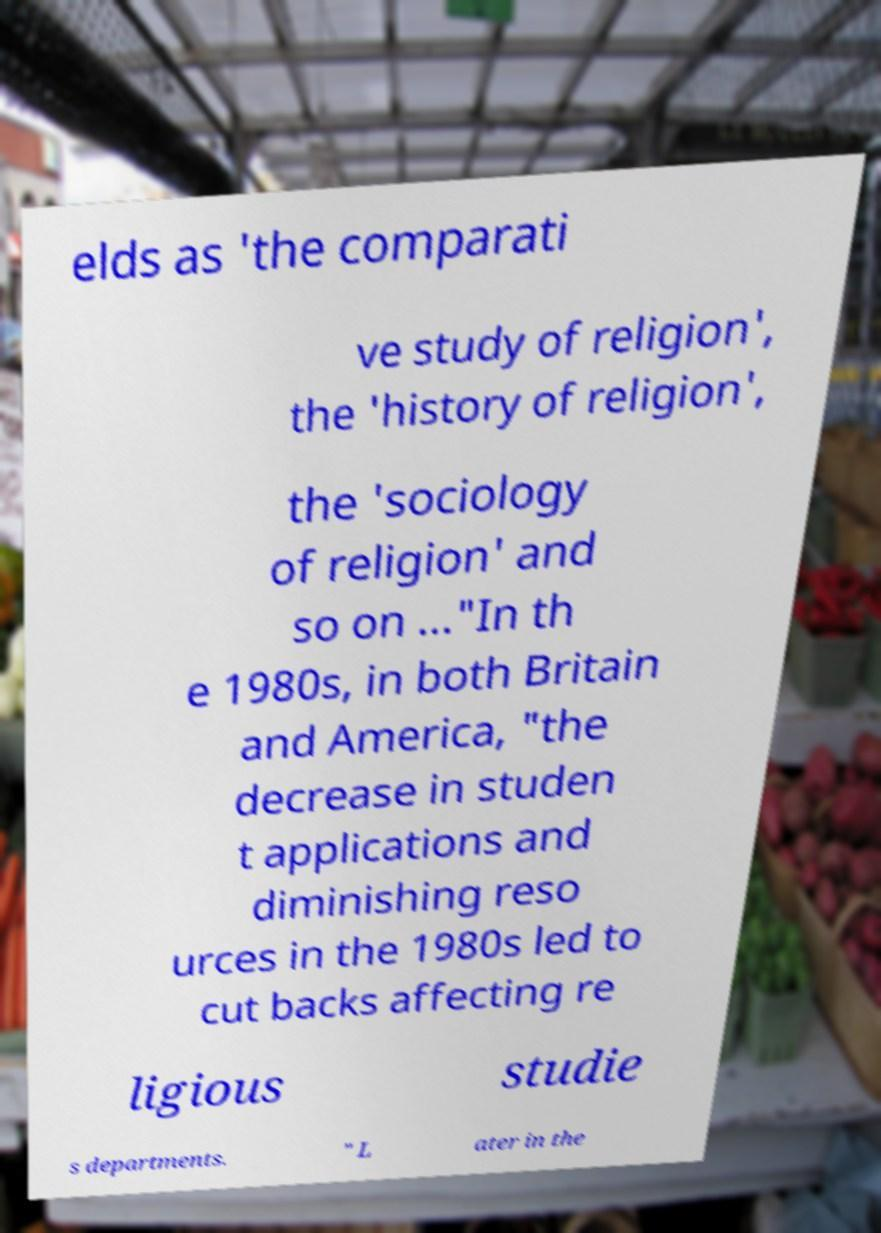Can you accurately transcribe the text from the provided image for me? elds as 'the comparati ve study of religion', the 'history of religion', the 'sociology of religion' and so on ..."In th e 1980s, in both Britain and America, "the decrease in studen t applications and diminishing reso urces in the 1980s led to cut backs affecting re ligious studie s departments. " L ater in the 